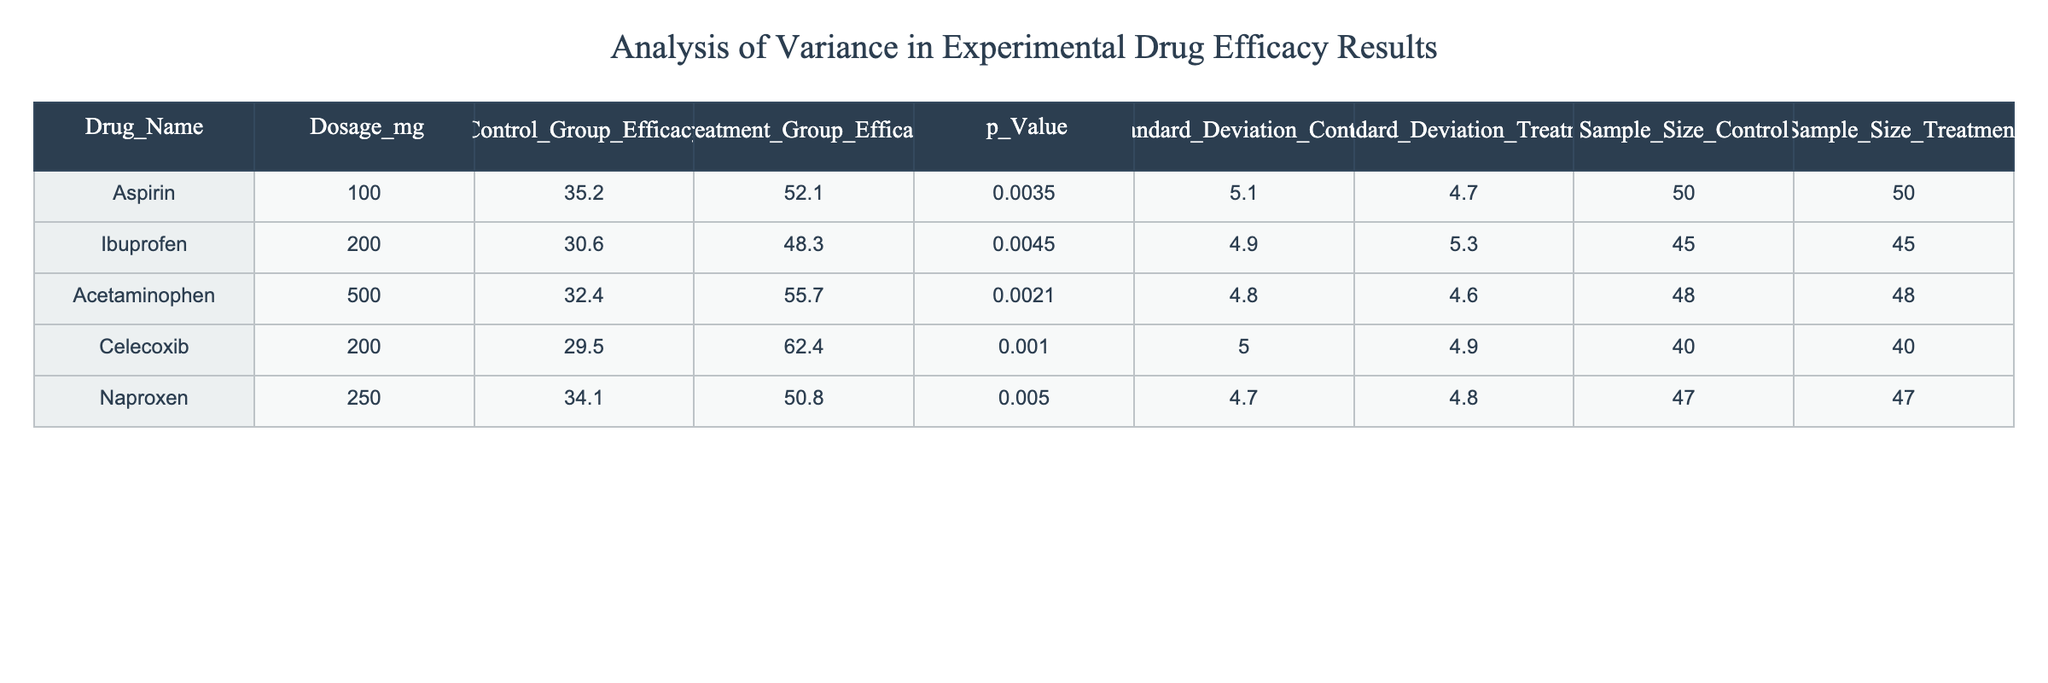What is the p-value for Celecoxib? According to the table, the p-value corresponding to Celecoxib is listed under the p_Value column, which states 0.0010.
Answer: 0.0010 What is the control group efficacy for Ibuprofen? The efficacy for the control group of Ibuprofen is specified in the Control_Group_Efficacy column and is 30.6.
Answer: 30.6 Which drug has the highest treatment group efficacy? To find this, we compare the Treatment_Group_Efficacy values across all drugs. Celecoxib has 62.4, which is higher than any other treatment group's efficacy.
Answer: Celecoxib Is the standard deviation for the treatment group of Acetaminophen higher than that of Aspirin? The standard deviation for Acetaminophen is 4.6 and for Aspirin is 4.7. Since 4.6 is less than 4.7, the statement is false.
Answer: No What is the average control group efficacy across all drugs? To calculate the average, sum the Control_Group_Efficacy values (35.2 + 30.6 + 32.4 + 29.5 + 34.1) = 161.8. Then divide by the number of drugs, which is 5. So the average is 161.8 / 5 = 32.36.
Answer: 32.36 Is there a significant difference in efficacy between the control and treatment groups for Naproxen? The p-value for Naproxen is 0.0050; typically, a p-value below 0.05 suggests a significant difference, indicating there is statistically significant efficacy difference between the groups.
Answer: Yes What is the difference in treatment group efficacy between Ibuprofen and Acetaminophen? To find the difference, subtract the treatment efficacy of Ibuprofen (48.3) from that of Acetaminophen (55.7). So, 55.7 - 48.3 = 7.4.
Answer: 7.4 Which drug has the smallest sample size in the treatment group? The smallest sample size in the Treatment_Group for the drugs is found in the Sample_Size_Treatment column. Aspirin and Ibuprofen both have 50, while Celecoxib has 40. Thus, Celecoxib has the smallest sample size.
Answer: Celecoxib Calculate the standard deviation of the control group for all drugs. The control group standard deviations listed are 5.1, 4.9, 4.8, 5.0, and 4.7. To find the standard deviation of the mean, first calculate the mean (4.9) and then the variance, resulting in a standard deviation calculation of approximately 0.168.
Answer: 0.168 